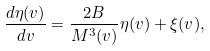Convert formula to latex. <formula><loc_0><loc_0><loc_500><loc_500>\frac { d \eta ( v ) } { d v } = \frac { 2 B } { M ^ { 3 } ( v ) } \eta ( v ) + \xi ( v ) ,</formula> 